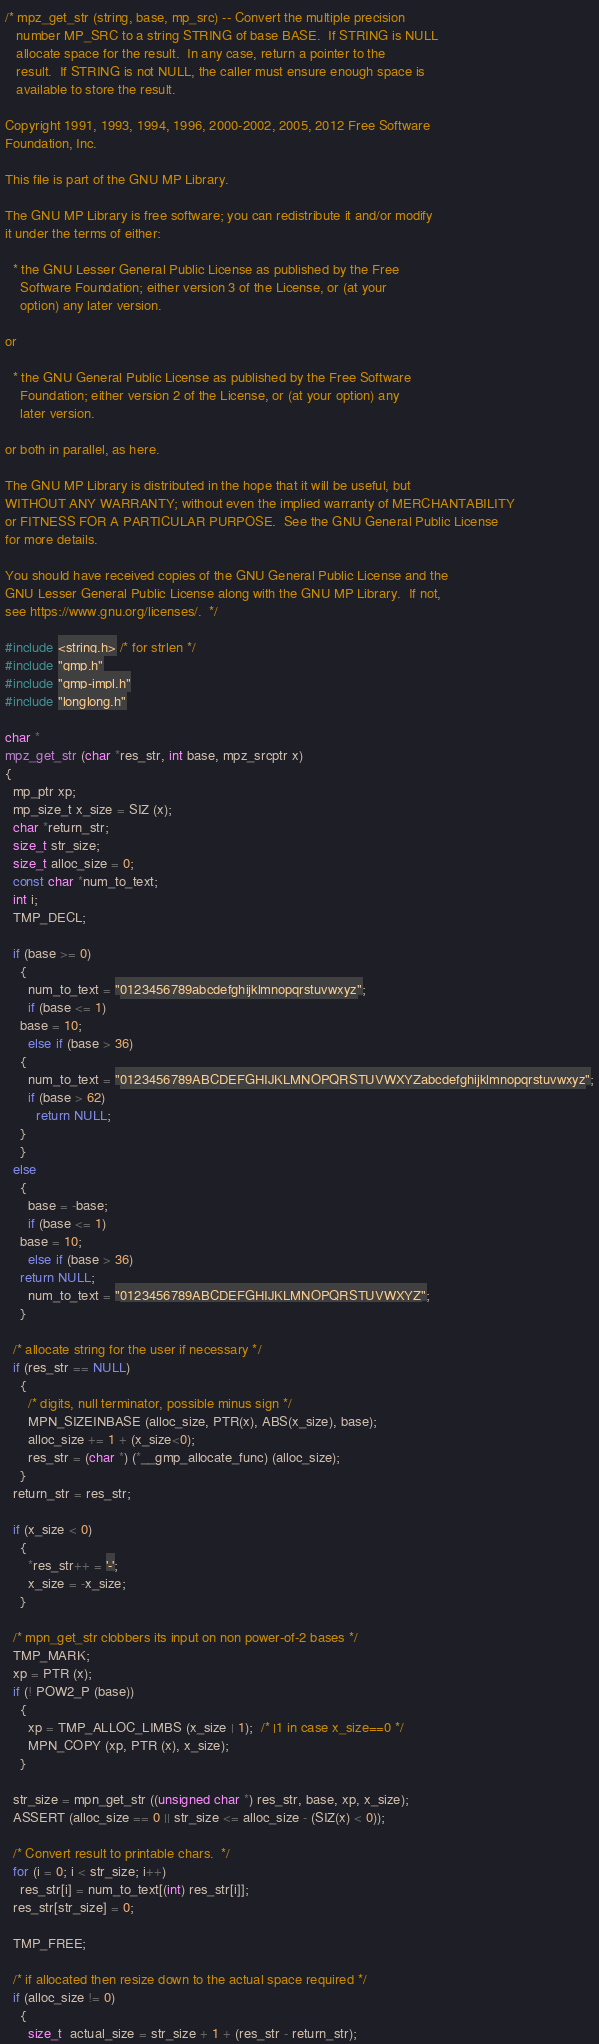Convert code to text. <code><loc_0><loc_0><loc_500><loc_500><_C_>/* mpz_get_str (string, base, mp_src) -- Convert the multiple precision
   number MP_SRC to a string STRING of base BASE.  If STRING is NULL
   allocate space for the result.  In any case, return a pointer to the
   result.  If STRING is not NULL, the caller must ensure enough space is
   available to store the result.

Copyright 1991, 1993, 1994, 1996, 2000-2002, 2005, 2012 Free Software
Foundation, Inc.

This file is part of the GNU MP Library.

The GNU MP Library is free software; you can redistribute it and/or modify
it under the terms of either:

  * the GNU Lesser General Public License as published by the Free
    Software Foundation; either version 3 of the License, or (at your
    option) any later version.

or

  * the GNU General Public License as published by the Free Software
    Foundation; either version 2 of the License, or (at your option) any
    later version.

or both in parallel, as here.

The GNU MP Library is distributed in the hope that it will be useful, but
WITHOUT ANY WARRANTY; without even the implied warranty of MERCHANTABILITY
or FITNESS FOR A PARTICULAR PURPOSE.  See the GNU General Public License
for more details.

You should have received copies of the GNU General Public License and the
GNU Lesser General Public License along with the GNU MP Library.  If not,
see https://www.gnu.org/licenses/.  */

#include <string.h> /* for strlen */
#include "gmp.h"
#include "gmp-impl.h"
#include "longlong.h"

char *
mpz_get_str (char *res_str, int base, mpz_srcptr x)
{
  mp_ptr xp;
  mp_size_t x_size = SIZ (x);
  char *return_str;
  size_t str_size;
  size_t alloc_size = 0;
  const char *num_to_text;
  int i;
  TMP_DECL;

  if (base >= 0)
    {
      num_to_text = "0123456789abcdefghijklmnopqrstuvwxyz";
      if (base <= 1)
	base = 10;
      else if (base > 36)
	{
	  num_to_text = "0123456789ABCDEFGHIJKLMNOPQRSTUVWXYZabcdefghijklmnopqrstuvwxyz";
	  if (base > 62)
	    return NULL;
	}
    }
  else
    {
      base = -base;
      if (base <= 1)
	base = 10;
      else if (base > 36)
	return NULL;
      num_to_text = "0123456789ABCDEFGHIJKLMNOPQRSTUVWXYZ";
    }

  /* allocate string for the user if necessary */
  if (res_str == NULL)
    {
      /* digits, null terminator, possible minus sign */
      MPN_SIZEINBASE (alloc_size, PTR(x), ABS(x_size), base);
      alloc_size += 1 + (x_size<0);
      res_str = (char *) (*__gmp_allocate_func) (alloc_size);
    }
  return_str = res_str;

  if (x_size < 0)
    {
      *res_str++ = '-';
      x_size = -x_size;
    }

  /* mpn_get_str clobbers its input on non power-of-2 bases */
  TMP_MARK;
  xp = PTR (x);
  if (! POW2_P (base))
    {
      xp = TMP_ALLOC_LIMBS (x_size | 1);  /* |1 in case x_size==0 */
      MPN_COPY (xp, PTR (x), x_size);
    }

  str_size = mpn_get_str ((unsigned char *) res_str, base, xp, x_size);
  ASSERT (alloc_size == 0 || str_size <= alloc_size - (SIZ(x) < 0));

  /* Convert result to printable chars.  */
  for (i = 0; i < str_size; i++)
    res_str[i] = num_to_text[(int) res_str[i]];
  res_str[str_size] = 0;

  TMP_FREE;

  /* if allocated then resize down to the actual space required */
  if (alloc_size != 0)
    {
      size_t  actual_size = str_size + 1 + (res_str - return_str);</code> 